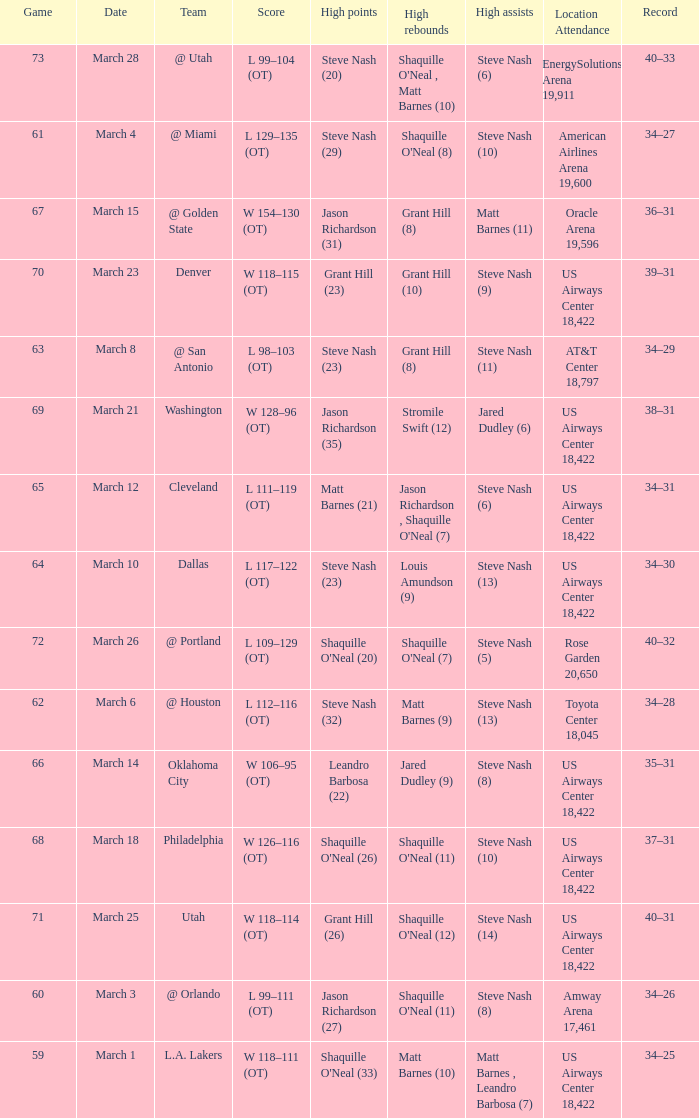After the March 15 game, what was the team's record? 36–31. 